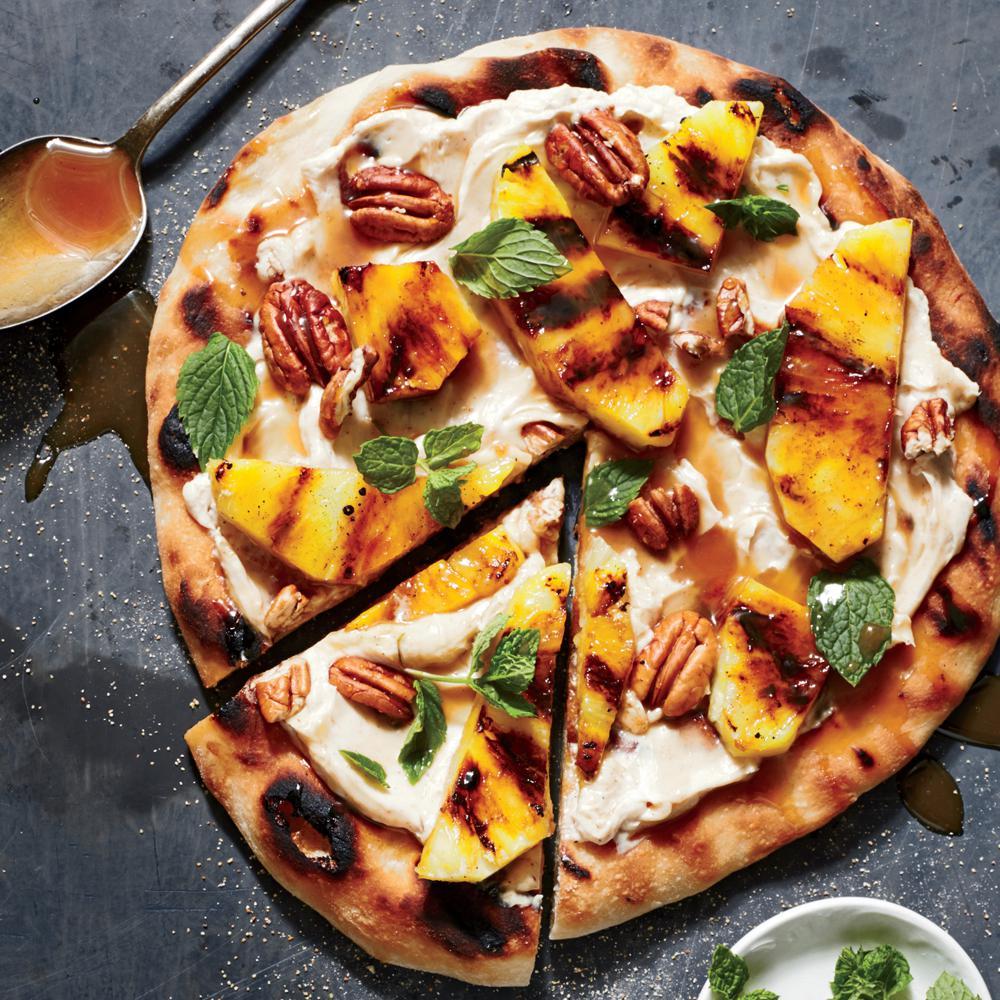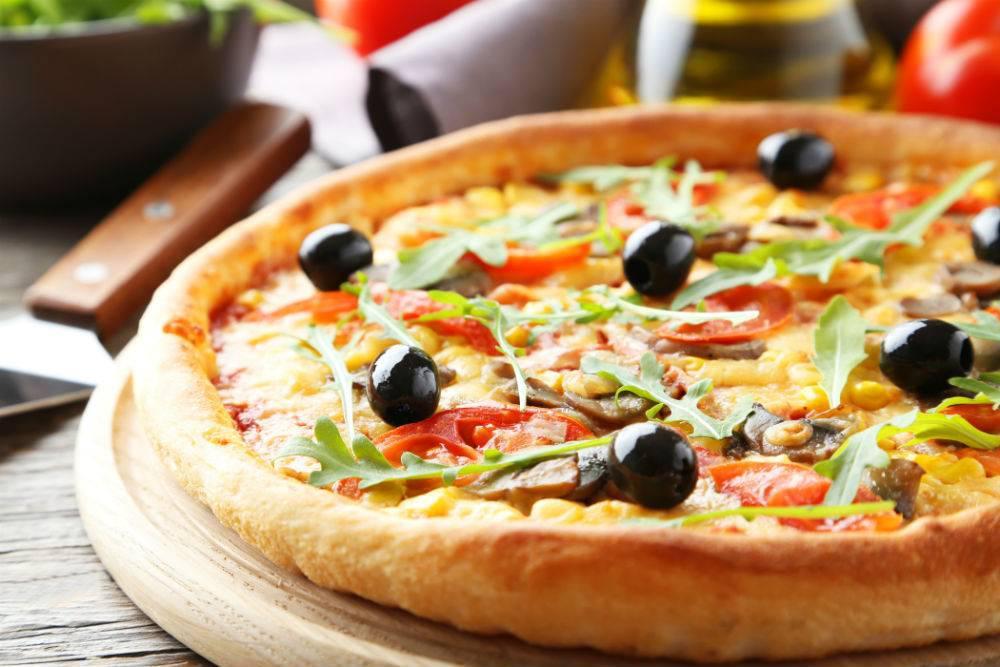The first image is the image on the left, the second image is the image on the right. Given the left and right images, does the statement "Several pizzas sit on a rack in one of the images." hold true? Answer yes or no. No. The first image is the image on the left, the second image is the image on the right. Given the left and right images, does the statement "One image shows multiple round pizzas on a metal grating." hold true? Answer yes or no. No. 